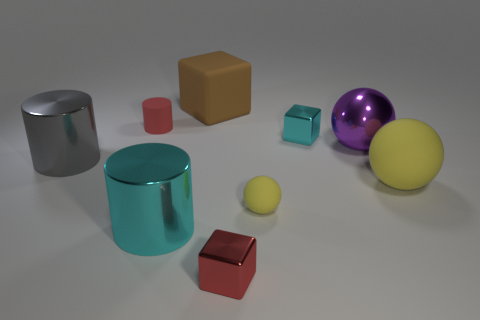Subtract all yellow blocks. Subtract all red cylinders. How many blocks are left? 3 Add 1 gray shiny objects. How many objects exist? 10 Subtract all cylinders. How many objects are left? 6 Add 9 large brown rubber blocks. How many large brown rubber blocks exist? 10 Subtract 0 blue cubes. How many objects are left? 9 Subtract all large yellow objects. Subtract all tiny red cylinders. How many objects are left? 7 Add 7 big cyan metallic things. How many big cyan metallic things are left? 8 